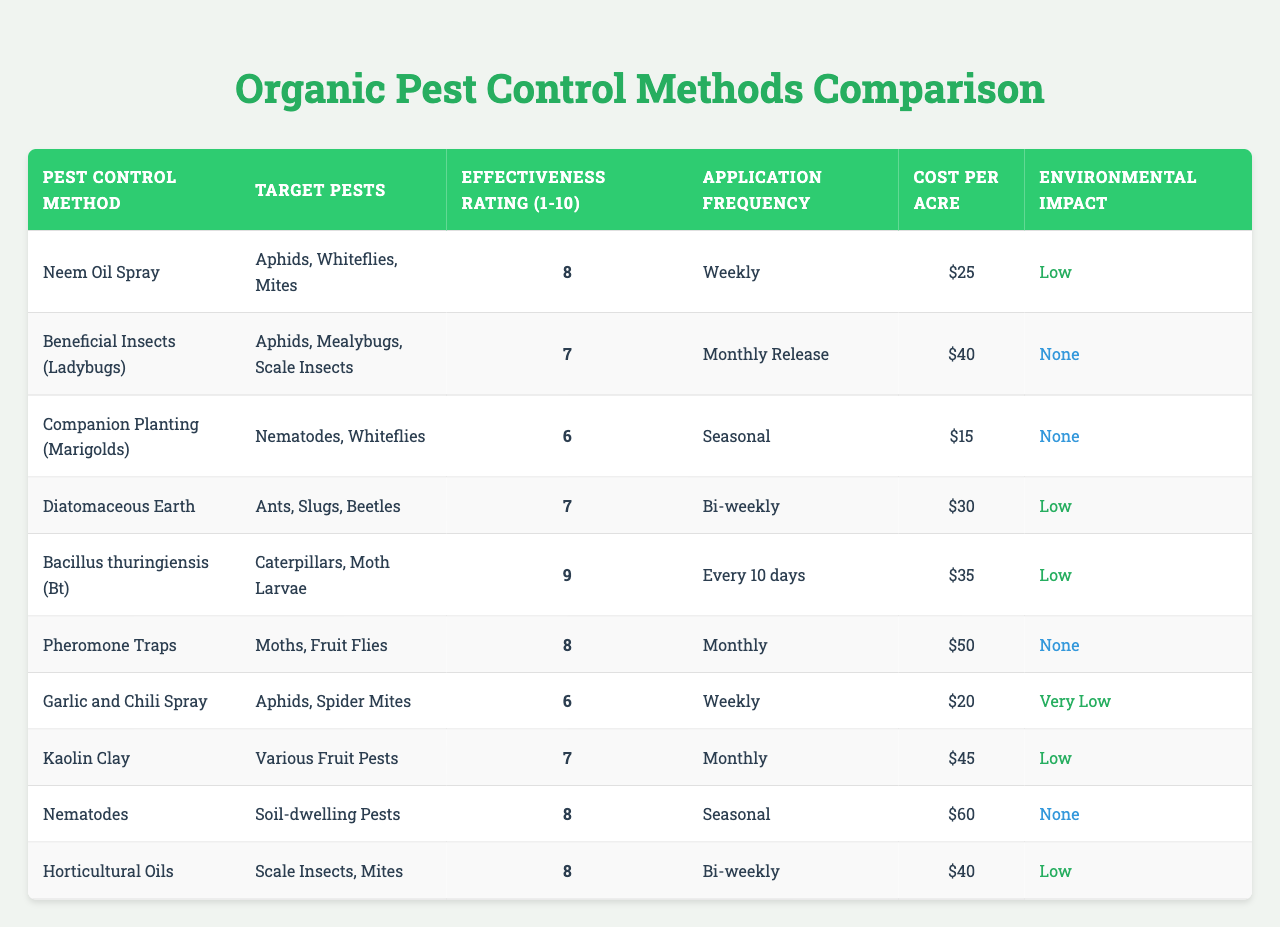What is the effectiveness rating of Neem Oil Spray? The table states that Neem Oil Spray has an effectiveness rating of 8.
Answer: 8 Which pest control method has the highest effectiveness rating? By reviewing the effectiveness ratings in the table, Bacillus thuringiensis (Bt) has the highest rating of 9.
Answer: Bacillus thuringiensis (Bt) How often should Diatomaceous Earth be applied? According to the table, Diatomaceous Earth should be applied bi-weekly.
Answer: Bi-weekly What is the cost per acre for using Nematodes? The table indicates that the cost per acre for using Nematodes is $60.
Answer: $60 Is Garlic and Chili Spray environmentally friendly? The environmental impact of Garlic and Chili Spray is marked as very low in the table, making it environmentally friendly.
Answer: Yes Which pest control method requires the least application frequency? Reviewing the table, Companion Planting (Marigolds) is applied seasonally, which is less frequent compared to others listed.
Answer: Companion Planting (Marigolds) What is the average effectiveness rating of the pest control methods listed? The effectiveness ratings are 8, 7, 6, 7, 9, 8, 6, 7, 8, and 8. The sum is 76, with 10 methods, resulting in an average of 76/10 = 7.6.
Answer: 7.6 How many methods have a low environmental impact? The table shows that 5 methods (Neem Oil Spray, Diatomaceous Earth, Bacillus thuringiensis (Bt), Horticultural Oils) indicate a low environmental impact, meaning 5 methods have a low impact.
Answer: 5 Is it true that Beneficial Insects have no environmental impact? According to the table, Beneficial Insects (Ladybugs) are listed as having no environmental impact, confirming the statement as true.
Answer: Yes Which pest control method is the most cost-effective based on cost per acre? The costs listed are $25, $40, $15, $30, $35, $50, $20, $45, $60, and $40. The lowest cost is $15 for Companion Planting (Marigolds), making it the most cost-effective.
Answer: Companion Planting (Marigolds) 